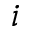<formula> <loc_0><loc_0><loc_500><loc_500>i</formula> 